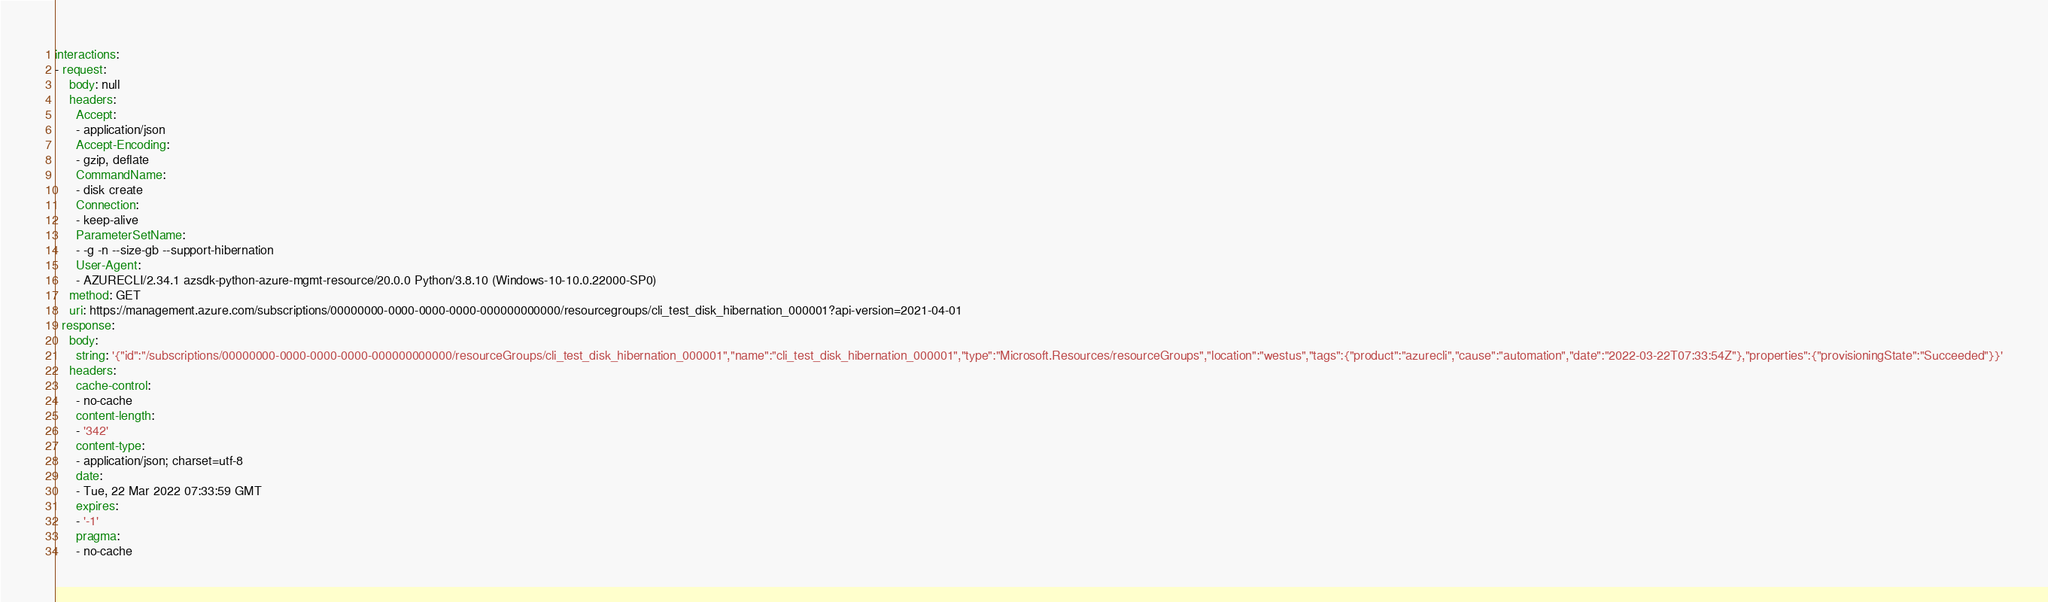<code> <loc_0><loc_0><loc_500><loc_500><_YAML_>interactions:
- request:
    body: null
    headers:
      Accept:
      - application/json
      Accept-Encoding:
      - gzip, deflate
      CommandName:
      - disk create
      Connection:
      - keep-alive
      ParameterSetName:
      - -g -n --size-gb --support-hibernation
      User-Agent:
      - AZURECLI/2.34.1 azsdk-python-azure-mgmt-resource/20.0.0 Python/3.8.10 (Windows-10-10.0.22000-SP0)
    method: GET
    uri: https://management.azure.com/subscriptions/00000000-0000-0000-0000-000000000000/resourcegroups/cli_test_disk_hibernation_000001?api-version=2021-04-01
  response:
    body:
      string: '{"id":"/subscriptions/00000000-0000-0000-0000-000000000000/resourceGroups/cli_test_disk_hibernation_000001","name":"cli_test_disk_hibernation_000001","type":"Microsoft.Resources/resourceGroups","location":"westus","tags":{"product":"azurecli","cause":"automation","date":"2022-03-22T07:33:54Z"},"properties":{"provisioningState":"Succeeded"}}'
    headers:
      cache-control:
      - no-cache
      content-length:
      - '342'
      content-type:
      - application/json; charset=utf-8
      date:
      - Tue, 22 Mar 2022 07:33:59 GMT
      expires:
      - '-1'
      pragma:
      - no-cache</code> 